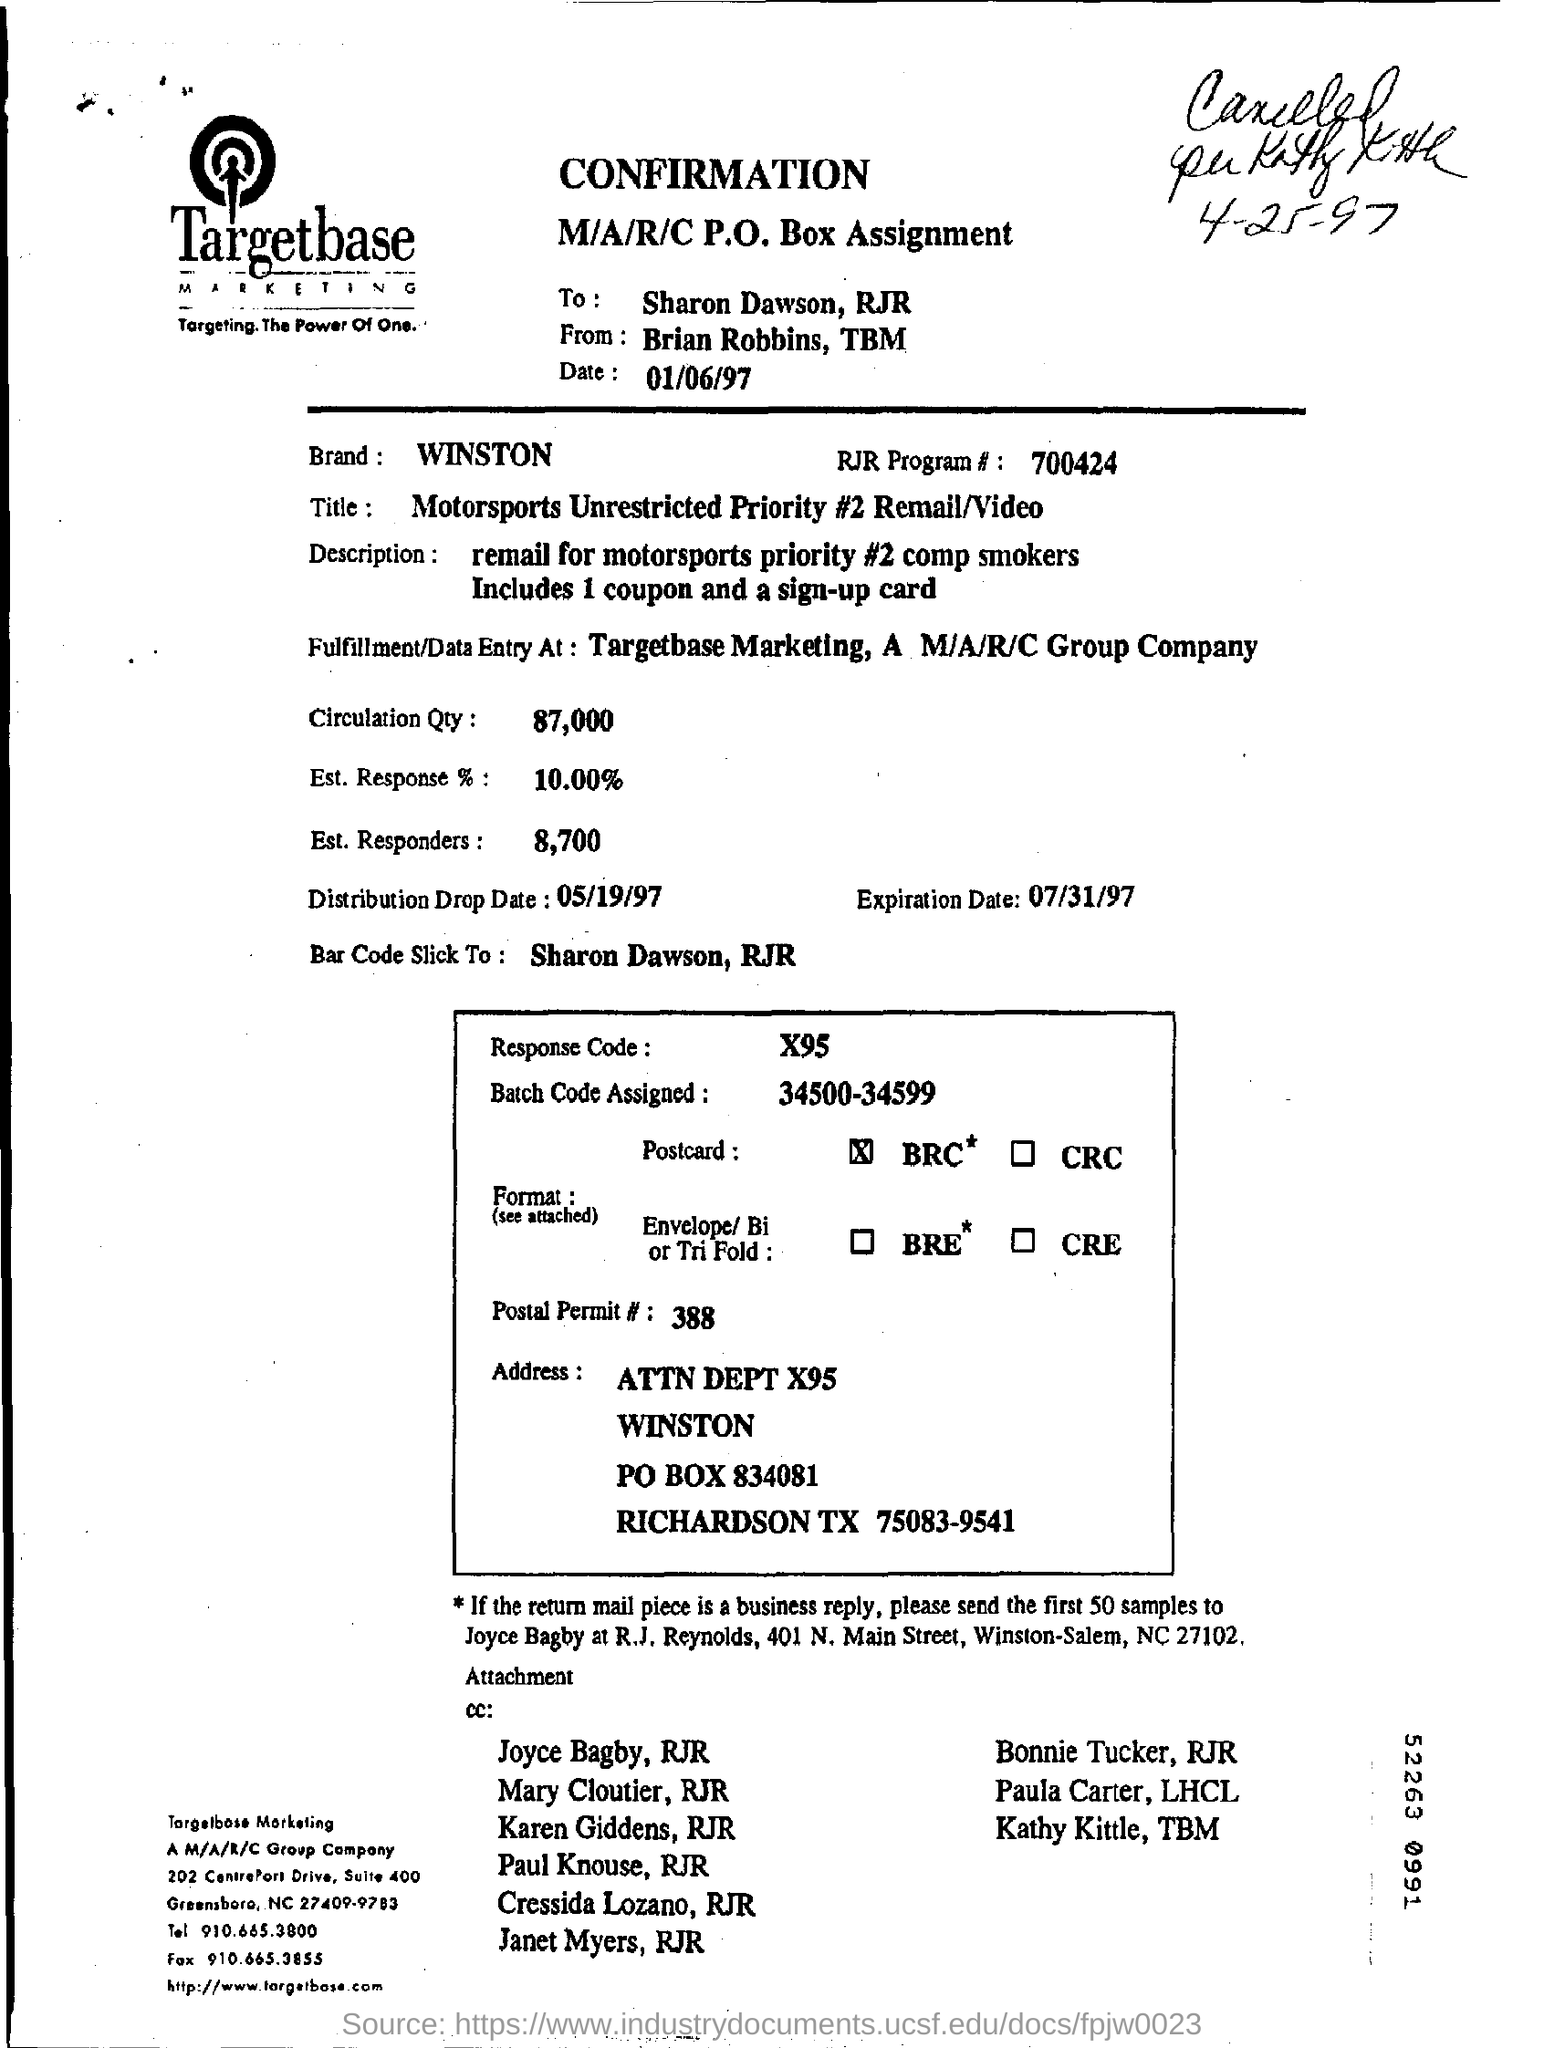What is the brand mentioned in the confirmation?
Provide a short and direct response. WINSTON. How many coupons did the motorsports priority includes?
Make the answer very short. 1 coupon. Who receives the samples of bussiness reply?
Keep it short and to the point. Joyce Bagby. Who send the confirmation to sharon dawson?
Make the answer very short. Brian Robbins, TBM. 